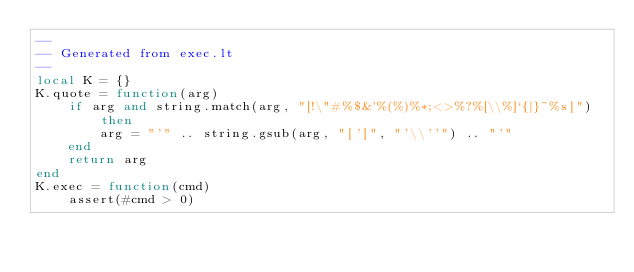Convert code to text. <code><loc_0><loc_0><loc_500><loc_500><_Lua_>--
-- Generated from exec.lt
--
local K = {}
K.quote = function(arg)
    if arg and string.match(arg, "[!\"#%$&'%(%)%*;<>%?%[\\%]`{|}~%s]") then
        arg = "'" .. string.gsub(arg, "[']", "'\\''") .. "'"
    end
    return arg
end
K.exec = function(cmd)
    assert(#cmd > 0)</code> 